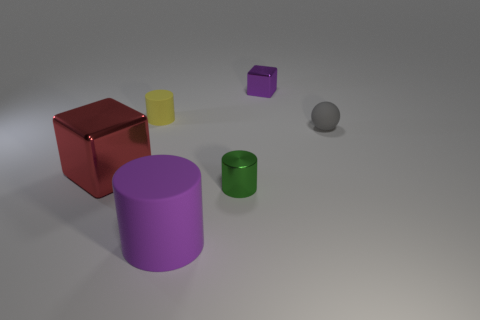Add 3 yellow rubber objects. How many objects exist? 9 Subtract all small cylinders. How many cylinders are left? 1 Add 5 tiny spheres. How many tiny spheres are left? 6 Add 1 green metallic things. How many green metallic things exist? 2 Subtract all yellow cylinders. How many cylinders are left? 2 Subtract 0 cyan cylinders. How many objects are left? 6 Subtract all blocks. How many objects are left? 4 Subtract 3 cylinders. How many cylinders are left? 0 Subtract all cyan cylinders. Subtract all brown cubes. How many cylinders are left? 3 Subtract all brown cylinders. How many brown spheres are left? 0 